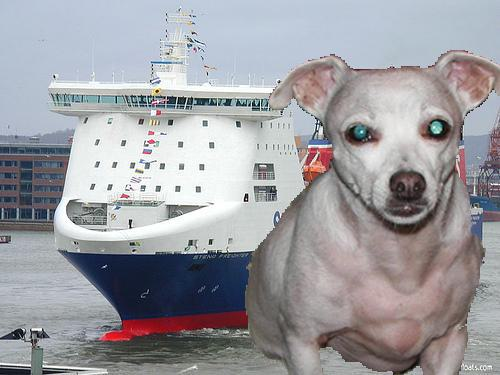What kind of ship is depicted in the background? The ship in the background appears to be a ferry, identifiable by its large structure designed to carry vehicles and passengers over water. 